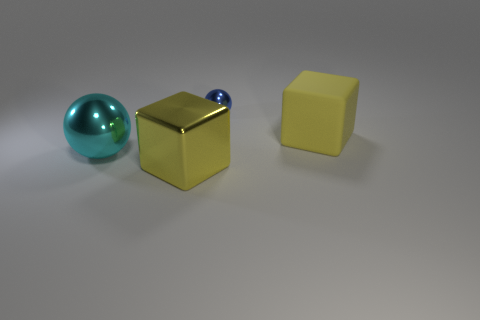Are there an equal number of shiny blocks behind the large yellow matte cube and blue shiny objects on the right side of the blue object?
Your answer should be very brief. Yes. How big is the metal object to the left of the large metallic cube?
Provide a succinct answer. Large. There is a big yellow thing that is on the left side of the metal ball that is behind the large sphere; what is it made of?
Give a very brief answer. Metal. How many big things are behind the ball in front of the thing that is on the right side of the blue sphere?
Provide a short and direct response. 1. Are the ball in front of the tiny blue thing and the tiny thing behind the matte cube made of the same material?
Your answer should be compact. Yes. There is another large block that is the same color as the shiny cube; what material is it?
Make the answer very short. Rubber. What number of small purple rubber things are the same shape as the yellow shiny thing?
Give a very brief answer. 0. Are there more big yellow rubber objects that are in front of the big rubber block than yellow things?
Keep it short and to the point. No. There is a big thing that is on the right side of the metallic block in front of the object to the right of the blue object; what is its shape?
Your answer should be very brief. Cube. There is a small blue shiny thing on the left side of the yellow matte cube; is it the same shape as the metallic thing that is left of the metallic cube?
Offer a very short reply. Yes. 